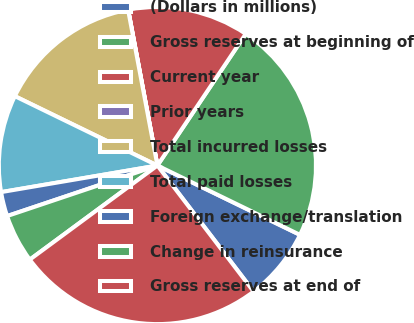Convert chart to OTSL. <chart><loc_0><loc_0><loc_500><loc_500><pie_chart><fcel>(Dollars in millions)<fcel>Gross reserves at beginning of<fcel>Current year<fcel>Prior years<fcel>Total incurred losses<fcel>Total paid losses<fcel>Foreign exchange/translation<fcel>Change in reinsurance<fcel>Gross reserves at end of<nl><fcel>7.42%<fcel>22.8%<fcel>12.36%<fcel>0.01%<fcel>14.83%<fcel>9.89%<fcel>2.48%<fcel>4.95%<fcel>25.27%<nl></chart> 